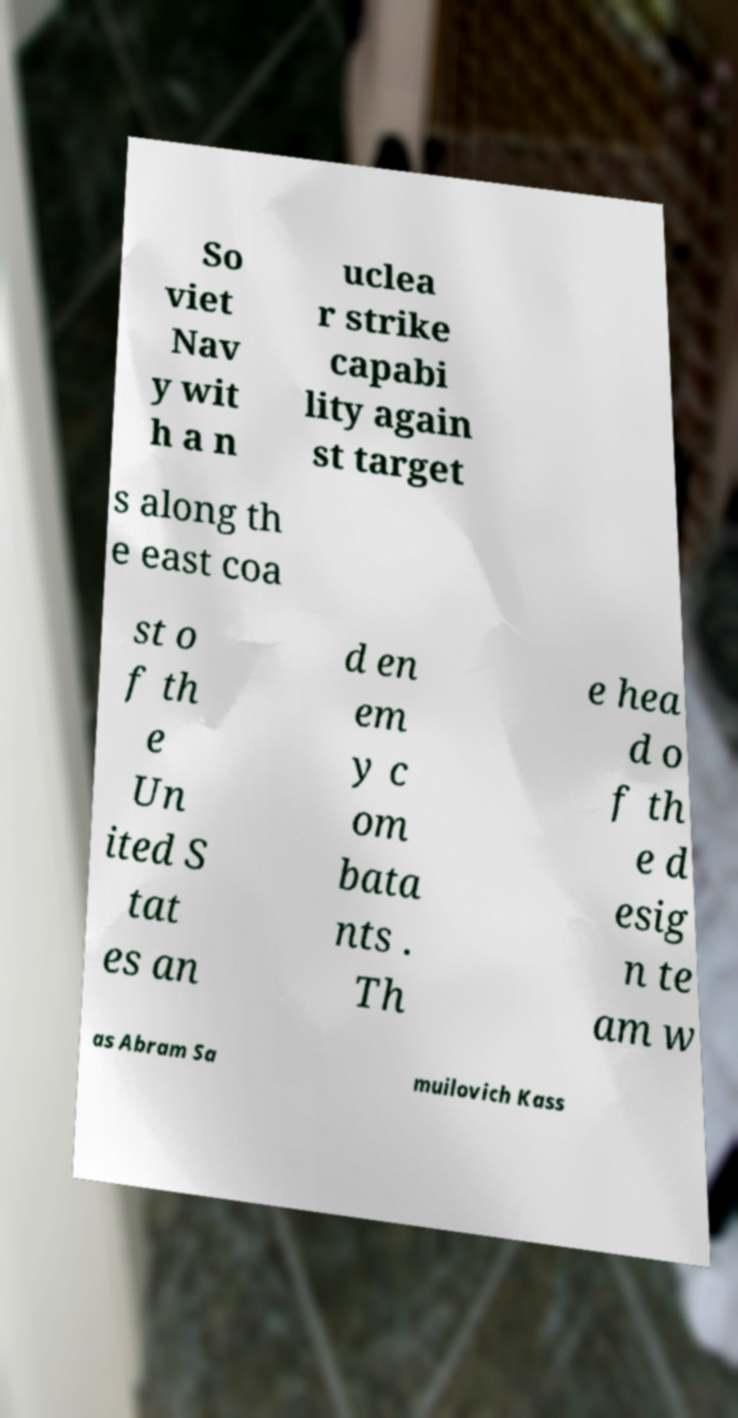Please identify and transcribe the text found in this image. So viet Nav y wit h a n uclea r strike capabi lity again st target s along th e east coa st o f th e Un ited S tat es an d en em y c om bata nts . Th e hea d o f th e d esig n te am w as Abram Sa muilovich Kass 